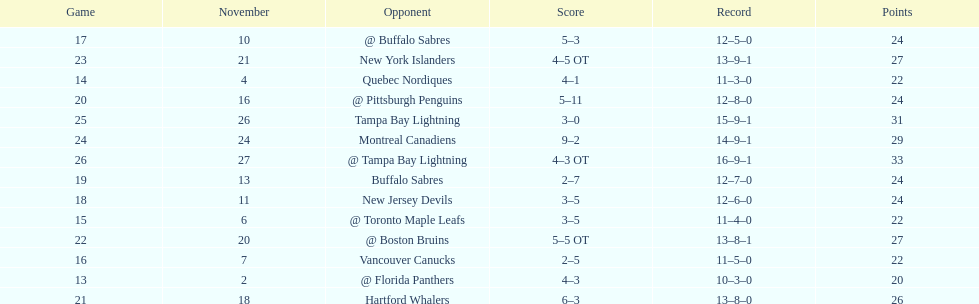What other team had the closest amount of wins? New York Islanders. 